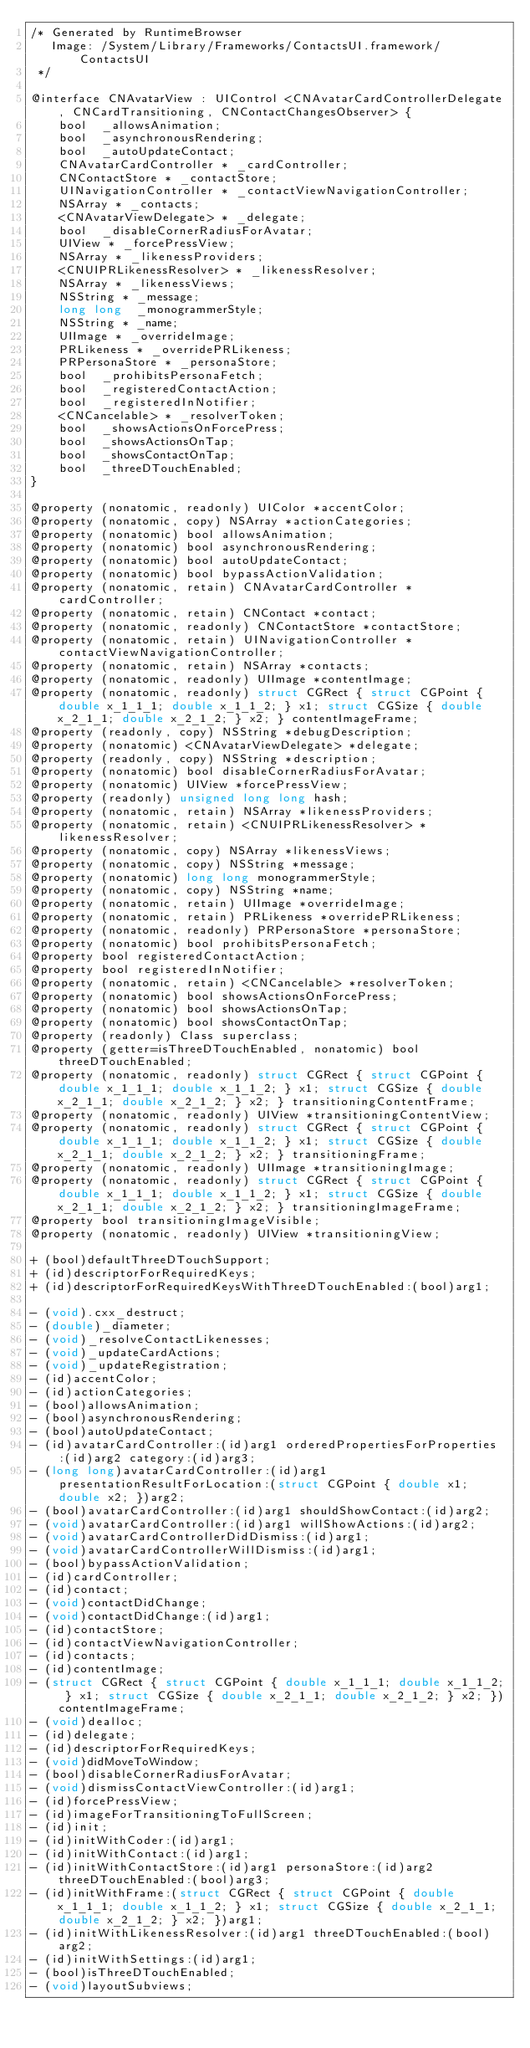<code> <loc_0><loc_0><loc_500><loc_500><_C_>/* Generated by RuntimeBrowser
   Image: /System/Library/Frameworks/ContactsUI.framework/ContactsUI
 */

@interface CNAvatarView : UIControl <CNAvatarCardControllerDelegate, CNCardTransitioning, CNContactChangesObserver> {
    bool  _allowsAnimation;
    bool  _asynchronousRendering;
    bool  _autoUpdateContact;
    CNAvatarCardController * _cardController;
    CNContactStore * _contactStore;
    UINavigationController * _contactViewNavigationController;
    NSArray * _contacts;
    <CNAvatarViewDelegate> * _delegate;
    bool  _disableCornerRadiusForAvatar;
    UIView * _forcePressView;
    NSArray * _likenessProviders;
    <CNUIPRLikenessResolver> * _likenessResolver;
    NSArray * _likenessViews;
    NSString * _message;
    long long  _monogrammerStyle;
    NSString * _name;
    UIImage * _overrideImage;
    PRLikeness * _overridePRLikeness;
    PRPersonaStore * _personaStore;
    bool  _prohibitsPersonaFetch;
    bool  _registeredContactAction;
    bool  _registeredInNotifier;
    <CNCancelable> * _resolverToken;
    bool  _showsActionsOnForcePress;
    bool  _showsActionsOnTap;
    bool  _showsContactOnTap;
    bool  _threeDTouchEnabled;
}

@property (nonatomic, readonly) UIColor *accentColor;
@property (nonatomic, copy) NSArray *actionCategories;
@property (nonatomic) bool allowsAnimation;
@property (nonatomic) bool asynchronousRendering;
@property (nonatomic) bool autoUpdateContact;
@property (nonatomic) bool bypassActionValidation;
@property (nonatomic, retain) CNAvatarCardController *cardController;
@property (nonatomic, retain) CNContact *contact;
@property (nonatomic, readonly) CNContactStore *contactStore;
@property (nonatomic, retain) UINavigationController *contactViewNavigationController;
@property (nonatomic, retain) NSArray *contacts;
@property (nonatomic, readonly) UIImage *contentImage;
@property (nonatomic, readonly) struct CGRect { struct CGPoint { double x_1_1_1; double x_1_1_2; } x1; struct CGSize { double x_2_1_1; double x_2_1_2; } x2; } contentImageFrame;
@property (readonly, copy) NSString *debugDescription;
@property (nonatomic) <CNAvatarViewDelegate> *delegate;
@property (readonly, copy) NSString *description;
@property (nonatomic) bool disableCornerRadiusForAvatar;
@property (nonatomic) UIView *forcePressView;
@property (readonly) unsigned long long hash;
@property (nonatomic, retain) NSArray *likenessProviders;
@property (nonatomic, retain) <CNUIPRLikenessResolver> *likenessResolver;
@property (nonatomic, copy) NSArray *likenessViews;
@property (nonatomic, copy) NSString *message;
@property (nonatomic) long long monogrammerStyle;
@property (nonatomic, copy) NSString *name;
@property (nonatomic, retain) UIImage *overrideImage;
@property (nonatomic, retain) PRLikeness *overridePRLikeness;
@property (nonatomic, readonly) PRPersonaStore *personaStore;
@property (nonatomic) bool prohibitsPersonaFetch;
@property bool registeredContactAction;
@property bool registeredInNotifier;
@property (nonatomic, retain) <CNCancelable> *resolverToken;
@property (nonatomic) bool showsActionsOnForcePress;
@property (nonatomic) bool showsActionsOnTap;
@property (nonatomic) bool showsContactOnTap;
@property (readonly) Class superclass;
@property (getter=isThreeDTouchEnabled, nonatomic) bool threeDTouchEnabled;
@property (nonatomic, readonly) struct CGRect { struct CGPoint { double x_1_1_1; double x_1_1_2; } x1; struct CGSize { double x_2_1_1; double x_2_1_2; } x2; } transitioningContentFrame;
@property (nonatomic, readonly) UIView *transitioningContentView;
@property (nonatomic, readonly) struct CGRect { struct CGPoint { double x_1_1_1; double x_1_1_2; } x1; struct CGSize { double x_2_1_1; double x_2_1_2; } x2; } transitioningFrame;
@property (nonatomic, readonly) UIImage *transitioningImage;
@property (nonatomic, readonly) struct CGRect { struct CGPoint { double x_1_1_1; double x_1_1_2; } x1; struct CGSize { double x_2_1_1; double x_2_1_2; } x2; } transitioningImageFrame;
@property bool transitioningImageVisible;
@property (nonatomic, readonly) UIView *transitioningView;

+ (bool)defaultThreeDTouchSupport;
+ (id)descriptorForRequiredKeys;
+ (id)descriptorForRequiredKeysWithThreeDTouchEnabled:(bool)arg1;

- (void).cxx_destruct;
- (double)_diameter;
- (void)_resolveContactLikenesses;
- (void)_updateCardActions;
- (void)_updateRegistration;
- (id)accentColor;
- (id)actionCategories;
- (bool)allowsAnimation;
- (bool)asynchronousRendering;
- (bool)autoUpdateContact;
- (id)avatarCardController:(id)arg1 orderedPropertiesForProperties:(id)arg2 category:(id)arg3;
- (long long)avatarCardController:(id)arg1 presentationResultForLocation:(struct CGPoint { double x1; double x2; })arg2;
- (bool)avatarCardController:(id)arg1 shouldShowContact:(id)arg2;
- (void)avatarCardController:(id)arg1 willShowActions:(id)arg2;
- (void)avatarCardControllerDidDismiss:(id)arg1;
- (void)avatarCardControllerWillDismiss:(id)arg1;
- (bool)bypassActionValidation;
- (id)cardController;
- (id)contact;
- (void)contactDidChange;
- (void)contactDidChange:(id)arg1;
- (id)contactStore;
- (id)contactViewNavigationController;
- (id)contacts;
- (id)contentImage;
- (struct CGRect { struct CGPoint { double x_1_1_1; double x_1_1_2; } x1; struct CGSize { double x_2_1_1; double x_2_1_2; } x2; })contentImageFrame;
- (void)dealloc;
- (id)delegate;
- (id)descriptorForRequiredKeys;
- (void)didMoveToWindow;
- (bool)disableCornerRadiusForAvatar;
- (void)dismissContactViewController:(id)arg1;
- (id)forcePressView;
- (id)imageForTransitioningToFullScreen;
- (id)init;
- (id)initWithCoder:(id)arg1;
- (id)initWithContact:(id)arg1;
- (id)initWithContactStore:(id)arg1 personaStore:(id)arg2 threeDTouchEnabled:(bool)arg3;
- (id)initWithFrame:(struct CGRect { struct CGPoint { double x_1_1_1; double x_1_1_2; } x1; struct CGSize { double x_2_1_1; double x_2_1_2; } x2; })arg1;
- (id)initWithLikenessResolver:(id)arg1 threeDTouchEnabled:(bool)arg2;
- (id)initWithSettings:(id)arg1;
- (bool)isThreeDTouchEnabled;
- (void)layoutSubviews;</code> 